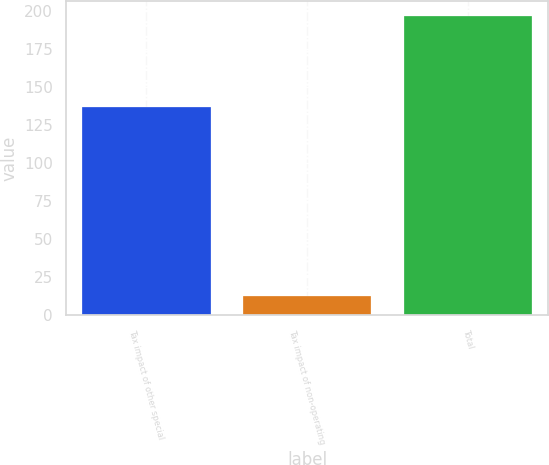<chart> <loc_0><loc_0><loc_500><loc_500><bar_chart><fcel>Tax impact of other special<fcel>Tax impact of non-operating<fcel>Total<nl><fcel>137<fcel>13<fcel>197<nl></chart> 